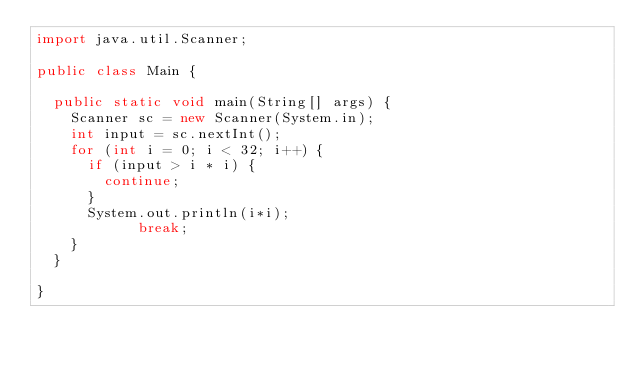Convert code to text. <code><loc_0><loc_0><loc_500><loc_500><_Java_>import java.util.Scanner;

public class Main {

	public static void main(String[] args) {
		Scanner sc = new Scanner(System.in);
		int input = sc.nextInt();
		for (int i = 0; i < 32; i++) {
			if (input > i * i) {
				continue;
			}
			System.out.println(i*i);
          	break;
		}
	}

}</code> 